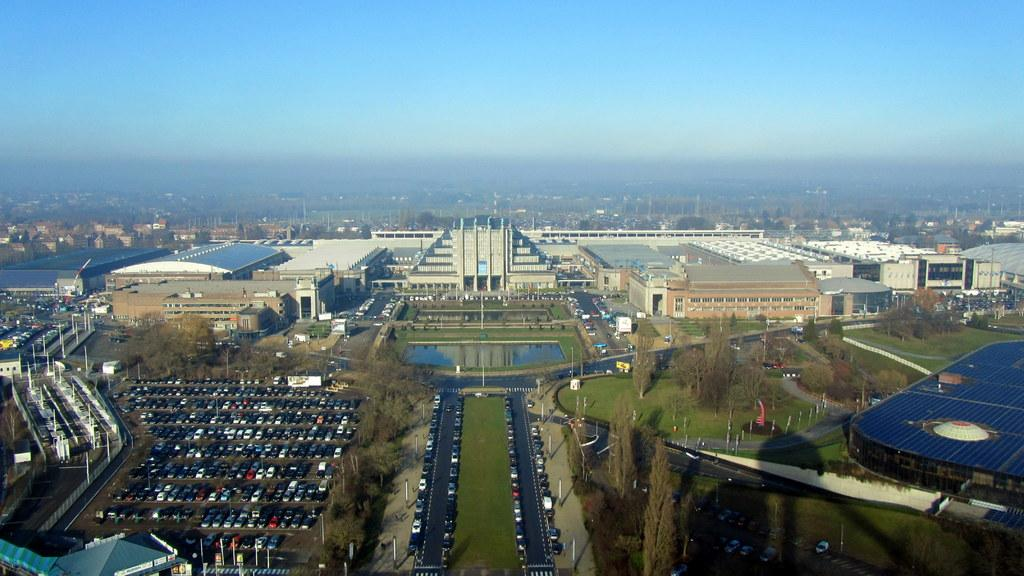What type of structures can be seen in the image? There are buildings in the image. What else is visible besides the buildings? There are vehicles and trees present in the image. Where are the trees located in the image? The trees are at the bottom of the image. What can be seen at the top of the image? The sky is visible at the top of the image. Can you tell me how many cacti are growing near the vehicles in the image? There are no cacti present in the image; it features buildings, vehicles, trees, and the sky. What type of engine is visible in the image? There is no engine visible in the image; it only shows buildings, vehicles, trees, and the sky. 